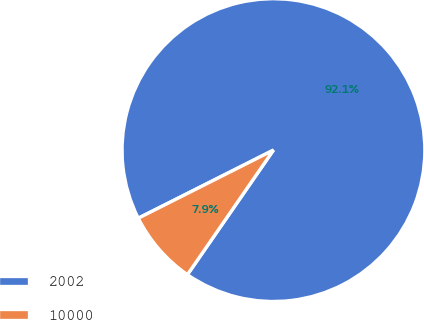<chart> <loc_0><loc_0><loc_500><loc_500><pie_chart><fcel>2002<fcel>10000<nl><fcel>92.05%<fcel>7.95%<nl></chart> 